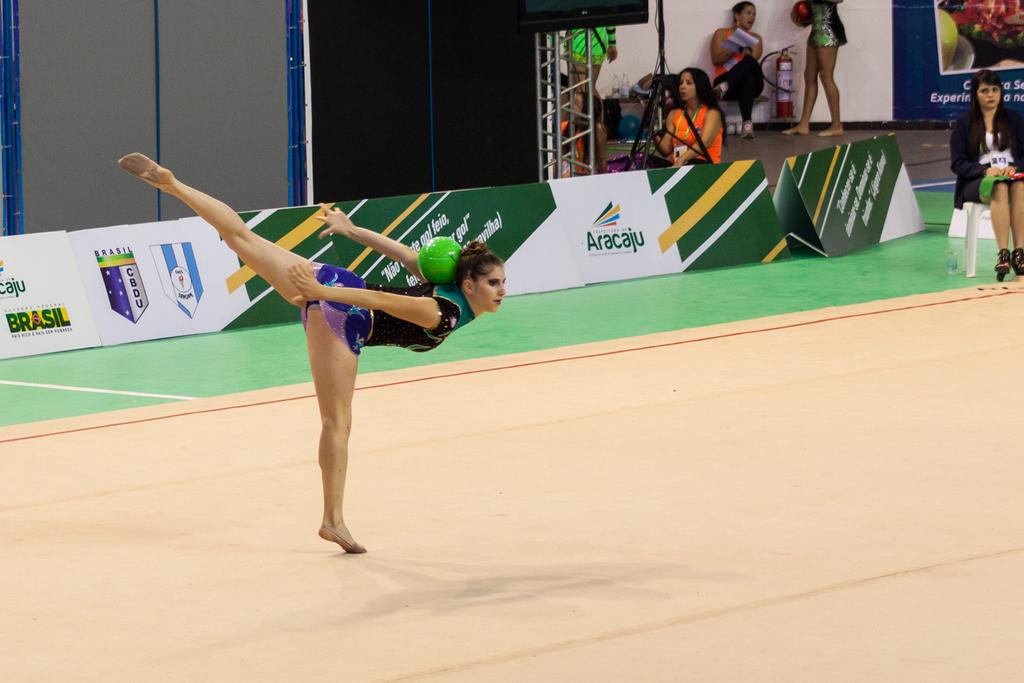What company is on the back banner?
Keep it short and to the point. Aracaju. 